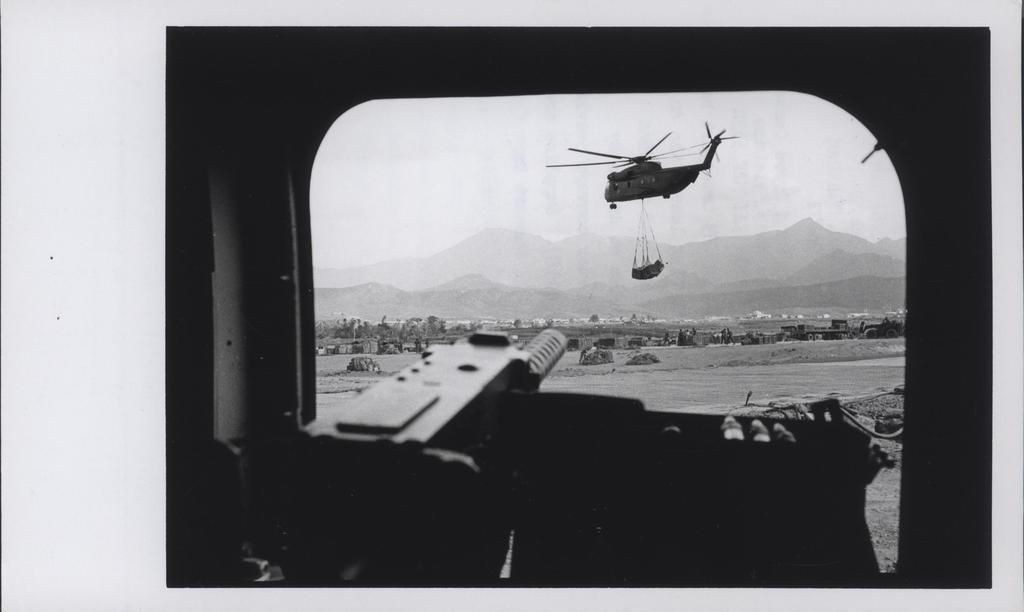What object is the main focus of the image? There is a gun in the image. What can be seen in the background of the image? There is a helicopter and hills visible in the background of the image. What type of vehicles are present in the image? There are vehicles in the image. What other natural elements can be seen in the image? There are trees in the image. What type of toys can be seen on the table in the image? There are no toys present in the image. Is there a lamp illuminating the scene in the image? There is no lamp visible in the image. 